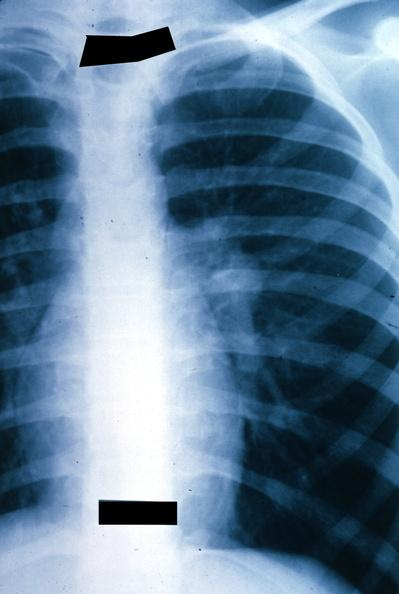s x-ray chest left hilar mass tumor in hilar node?
Answer the question using a single word or phrase. Yes 